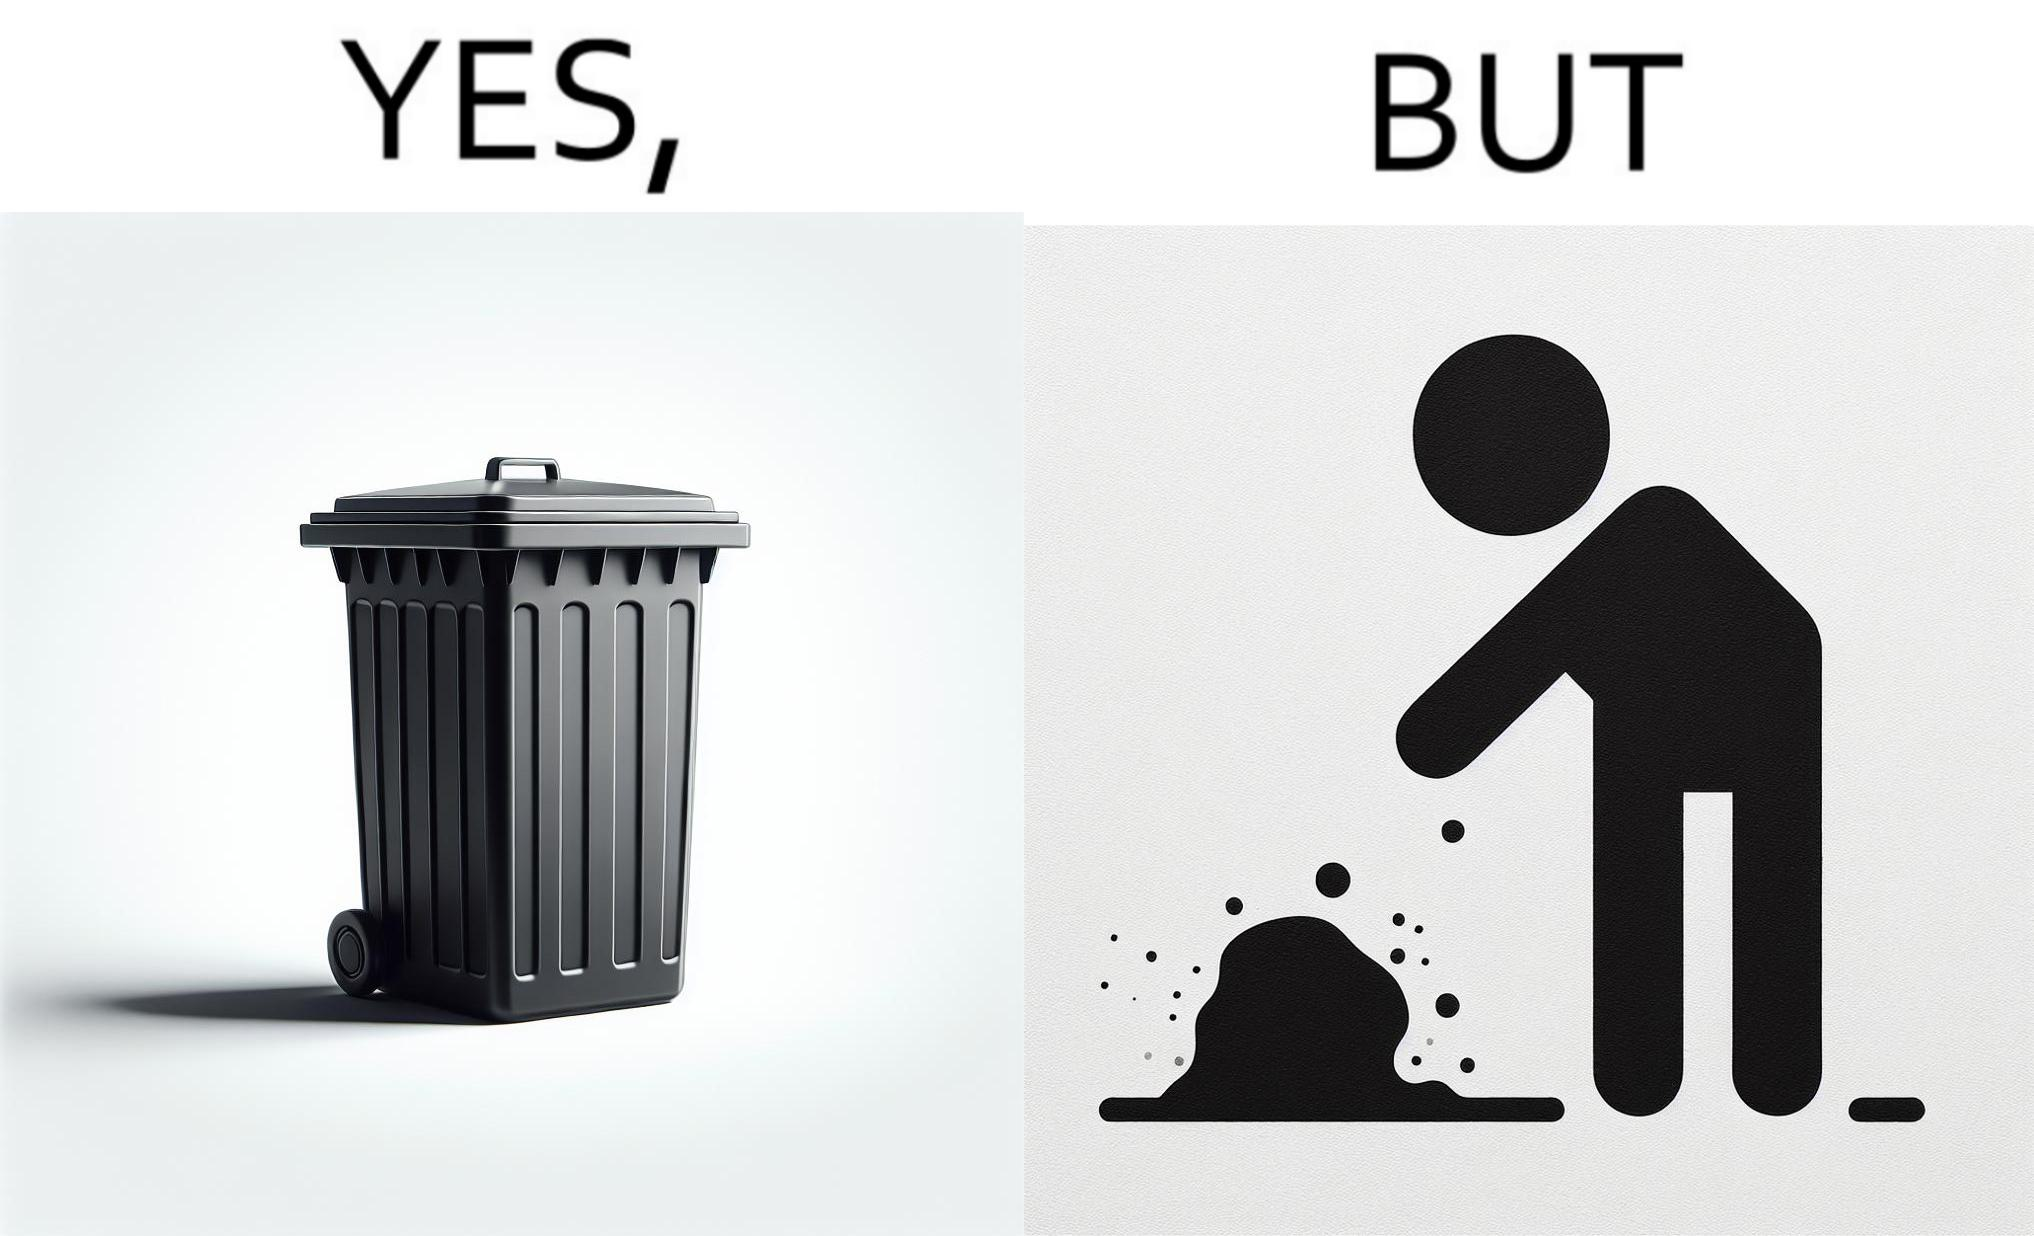Is this a satirical image? Yes, this image is satirical. 